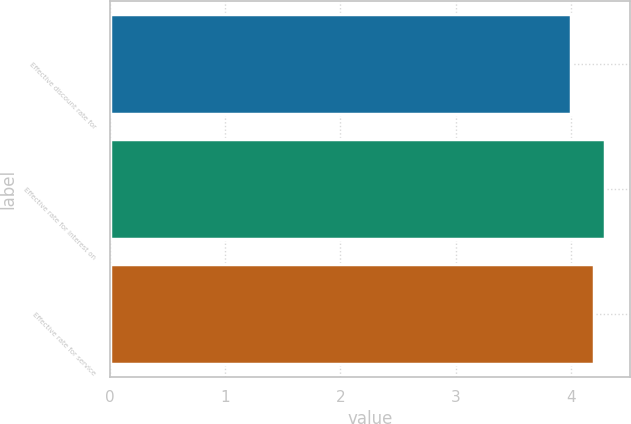<chart> <loc_0><loc_0><loc_500><loc_500><bar_chart><fcel>Effective discount rate for<fcel>Effective rate for interest on<fcel>Effective rate for service<nl><fcel>4<fcel>4.3<fcel>4.2<nl></chart> 